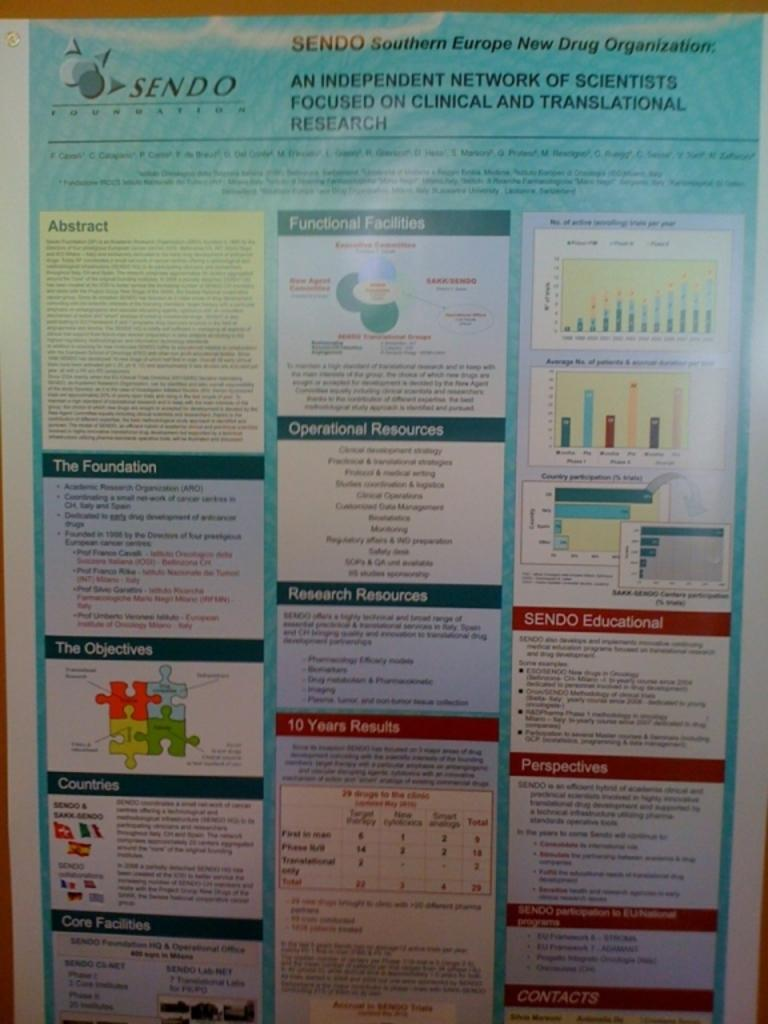<image>
Write a terse but informative summary of the picture. A group of posters from Sendo Southern Europe New Drug Organization. 